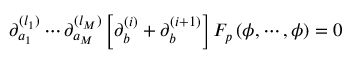Convert formula to latex. <formula><loc_0><loc_0><loc_500><loc_500>\partial _ { a _ { 1 } } ^ { ( l _ { 1 } ) } \cdots \partial _ { a _ { M } } ^ { ( l _ { M } ) } \left [ \partial _ { b } ^ { ( i ) } + \partial _ { b } ^ { ( i + 1 ) } \right ] F _ { p } \, ( \phi , \cdots , \phi ) = 0</formula> 